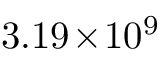Convert formula to latex. <formula><loc_0><loc_0><loc_500><loc_500>3 . 1 9 \, \times \, 1 0 ^ { 9 }</formula> 